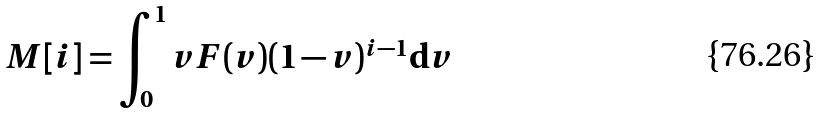<formula> <loc_0><loc_0><loc_500><loc_500>M [ i ] = \int _ { 0 } ^ { 1 } v F ( v ) ( 1 - v ) ^ { i - 1 } { \mathrm d } v</formula> 